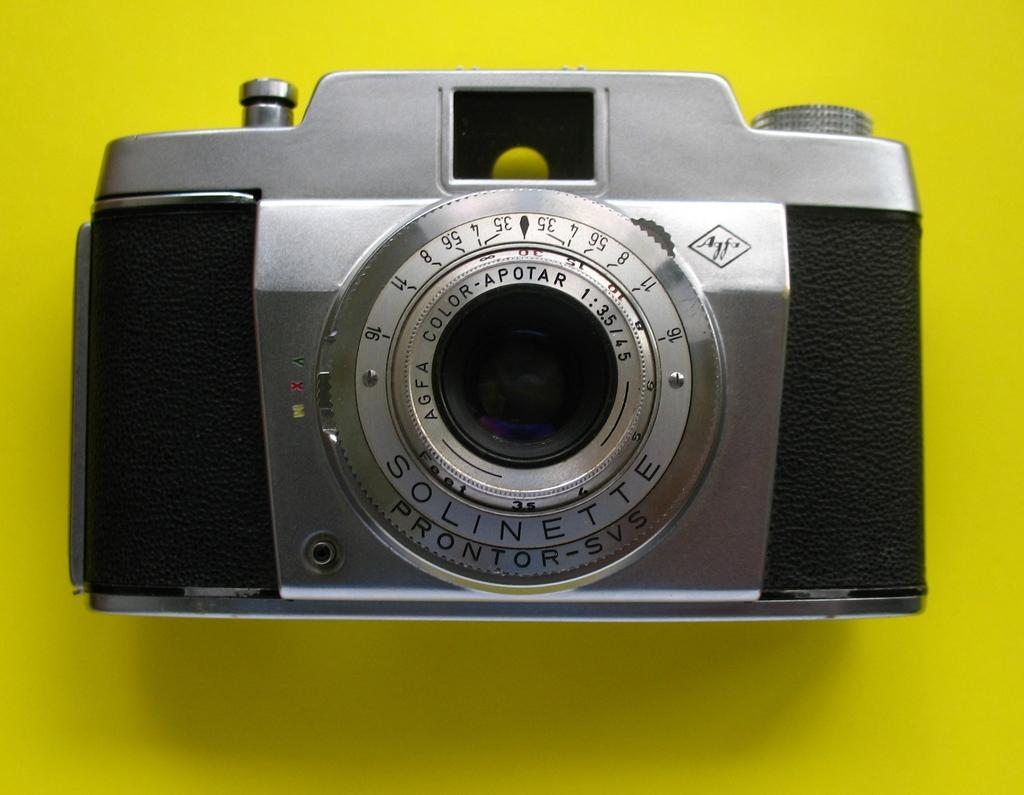What is the main object in the picture? There is a camera in the picture. What color is the background of the image? The background of the image is yellow in color. Where is the grandmother sitting with her sack of yarn in the image? There is no grandmother or sack of yarn present in the image; it only features a camera and a yellow background. 